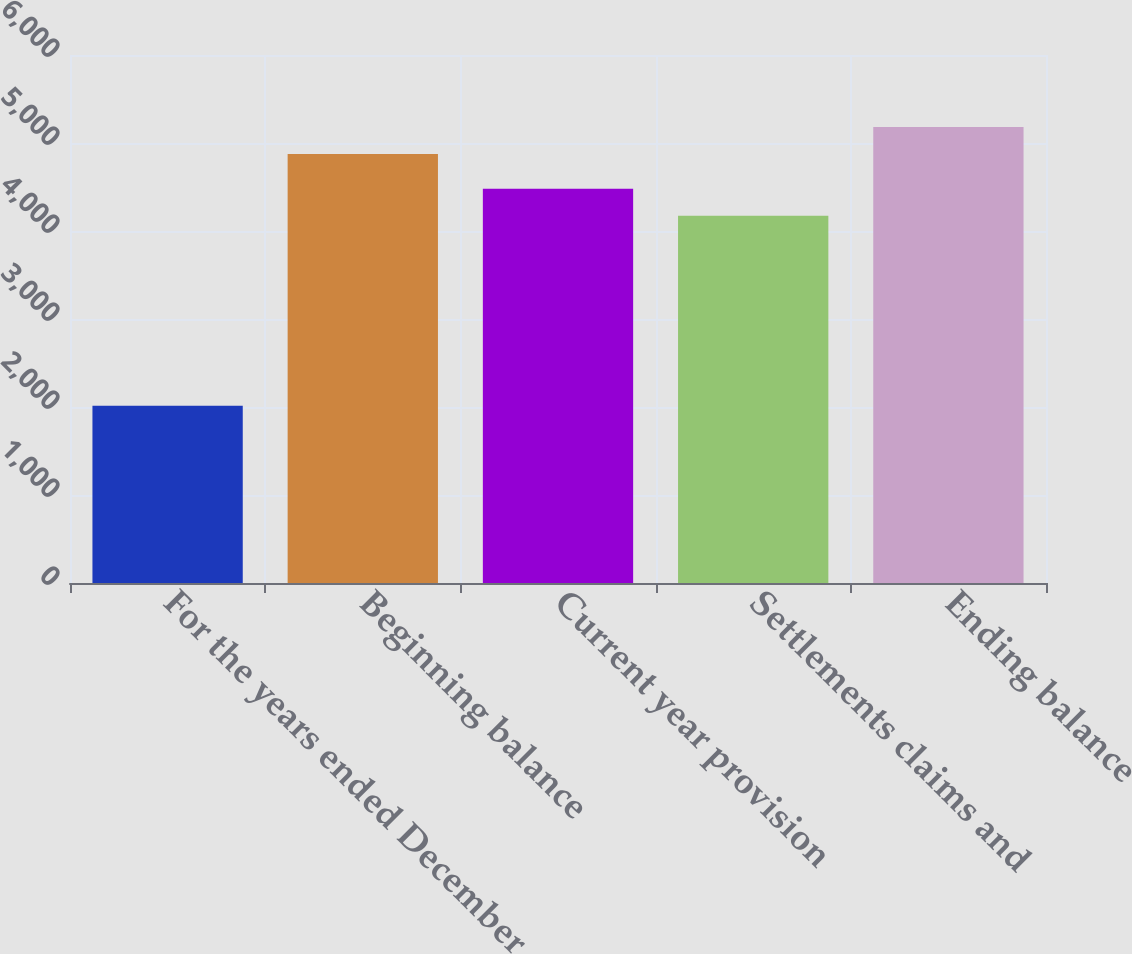Convert chart to OTSL. <chart><loc_0><loc_0><loc_500><loc_500><bar_chart><fcel>For the years ended December<fcel>Beginning balance<fcel>Current year provision<fcel>Settlements claims and<fcel>Ending balance<nl><fcel>2015<fcel>4875<fcel>4481<fcel>4174<fcel>5182<nl></chart> 